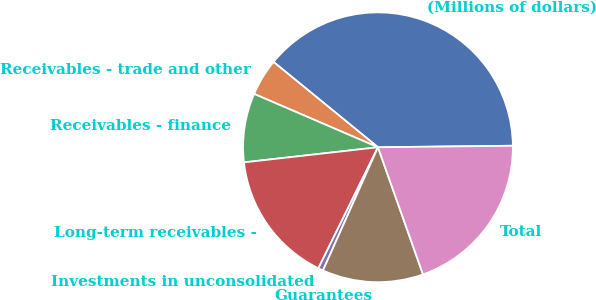Convert chart. <chart><loc_0><loc_0><loc_500><loc_500><pie_chart><fcel>(Millions of dollars)<fcel>Receivables - trade and other<fcel>Receivables - finance<fcel>Long-term receivables -<fcel>Investments in unconsolidated<fcel>Guarantees<fcel>Total<nl><fcel>38.92%<fcel>4.43%<fcel>8.26%<fcel>15.93%<fcel>0.6%<fcel>12.1%<fcel>19.76%<nl></chart> 